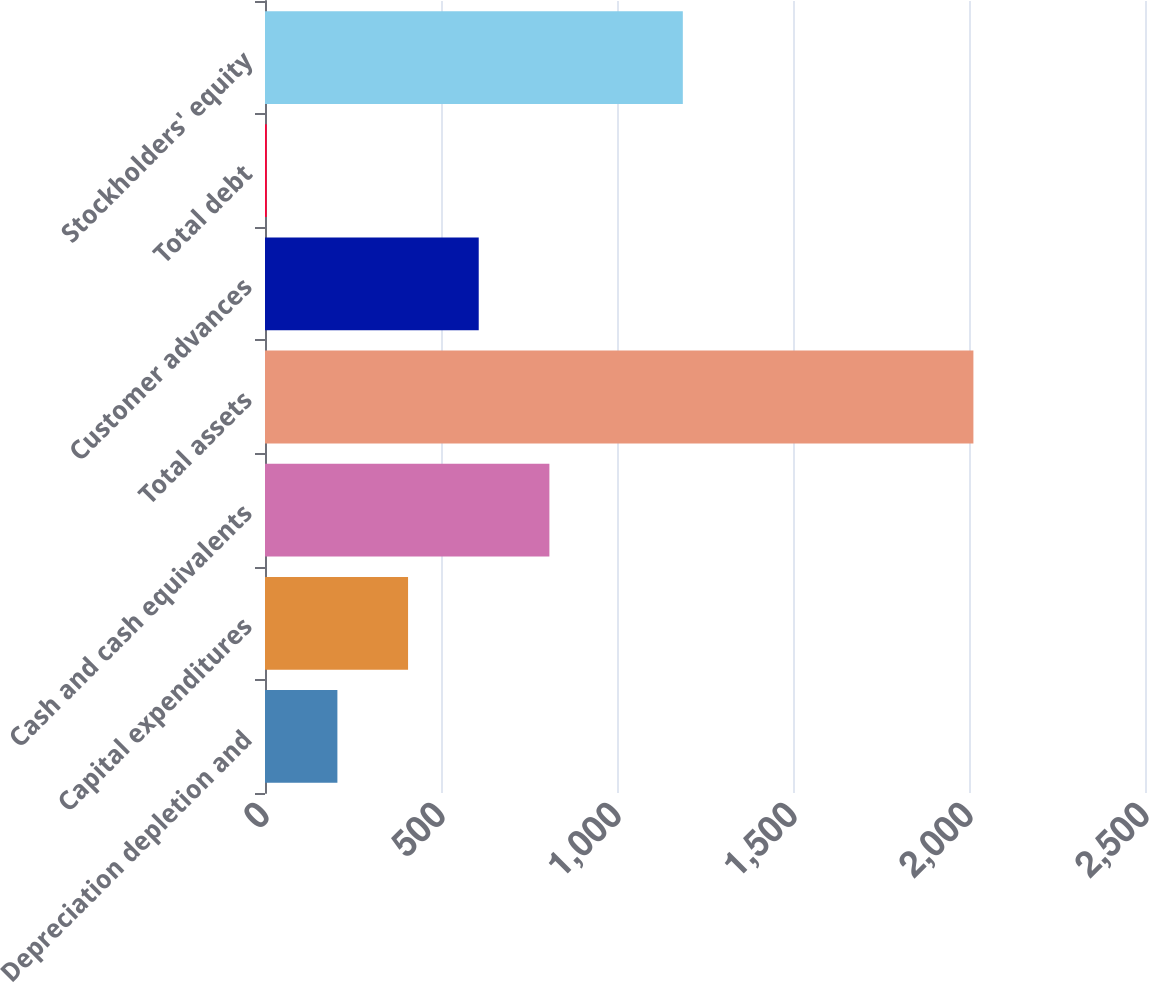<chart> <loc_0><loc_0><loc_500><loc_500><bar_chart><fcel>Depreciation depletion and<fcel>Capital expenditures<fcel>Cash and cash equivalents<fcel>Total assets<fcel>Customer advances<fcel>Total debt<fcel>Stockholders' equity<nl><fcel>205.66<fcel>406.42<fcel>807.94<fcel>2012.5<fcel>607.18<fcel>4.9<fcel>1187<nl></chart> 